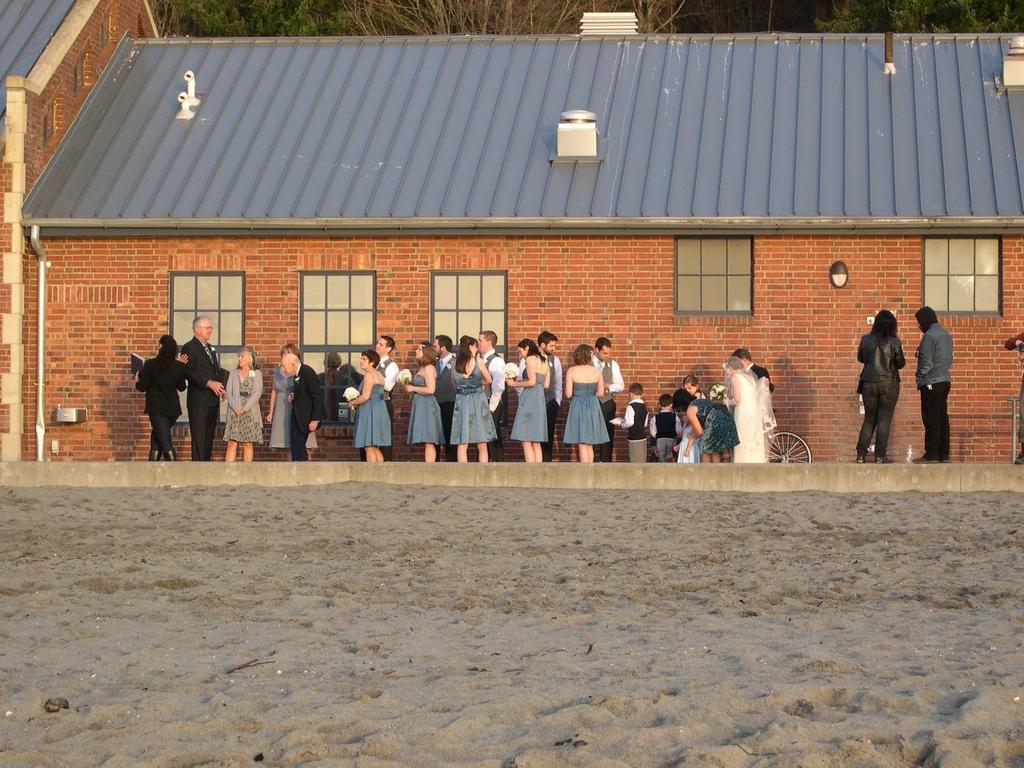In one or two sentences, can you explain what this image depicts? Front of the image we can see sand. Here we can see people,wall,windows and roof top. Background we can see trees. 